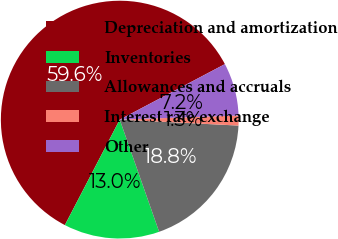<chart> <loc_0><loc_0><loc_500><loc_500><pie_chart><fcel>Depreciation and amortization<fcel>Inventories<fcel>Allowances and accruals<fcel>Interest rate exchange<fcel>Other<nl><fcel>59.64%<fcel>13.01%<fcel>18.83%<fcel>1.35%<fcel>7.18%<nl></chart> 